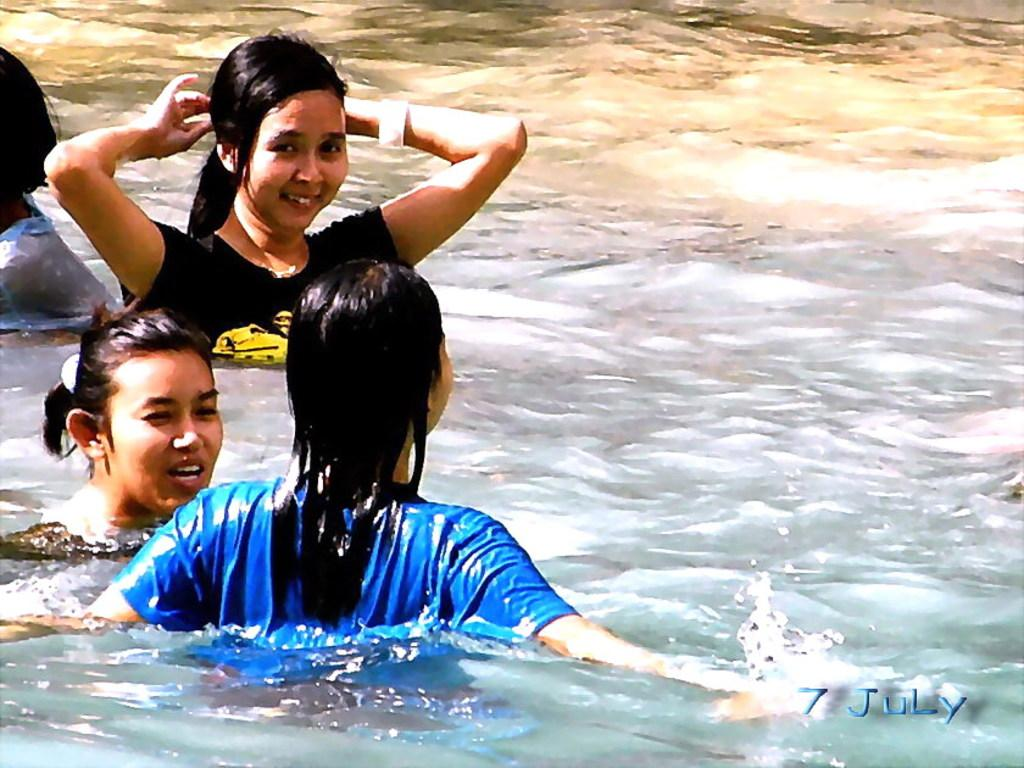What are the people in the image doing? The people in the image are in the water on the left side. Can you describe the facial expression of one of the individuals in the image? A woman is smiling in the image. Where is the watermark located in the image? The watermark is on the right side bottom of the image. What type of nose can be seen on the woman in the image? There is no specific nose visible on the woman in the image, as we cannot see her face clearly. How does the wind affect the water in the image? The image does not provide any information about the wind or its effects on the water. 